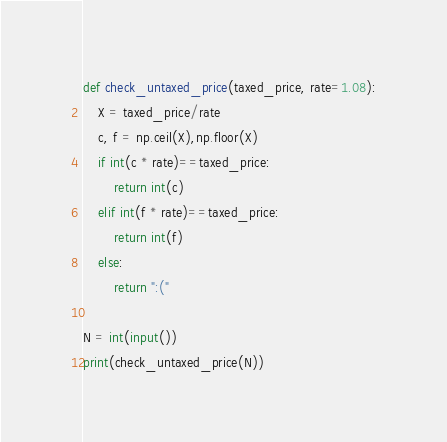<code> <loc_0><loc_0><loc_500><loc_500><_Python_>def check_untaxed_price(taxed_price, rate=1.08):
    X = taxed_price/rate
    c, f = np.ceil(X),np.floor(X)
    if int(c * rate)==taxed_price:
        return int(c)
    elif int(f * rate)==taxed_price:
        return int(f)
    else:
        return ":("

N = int(input())
print(check_untaxed_price(N))
</code> 